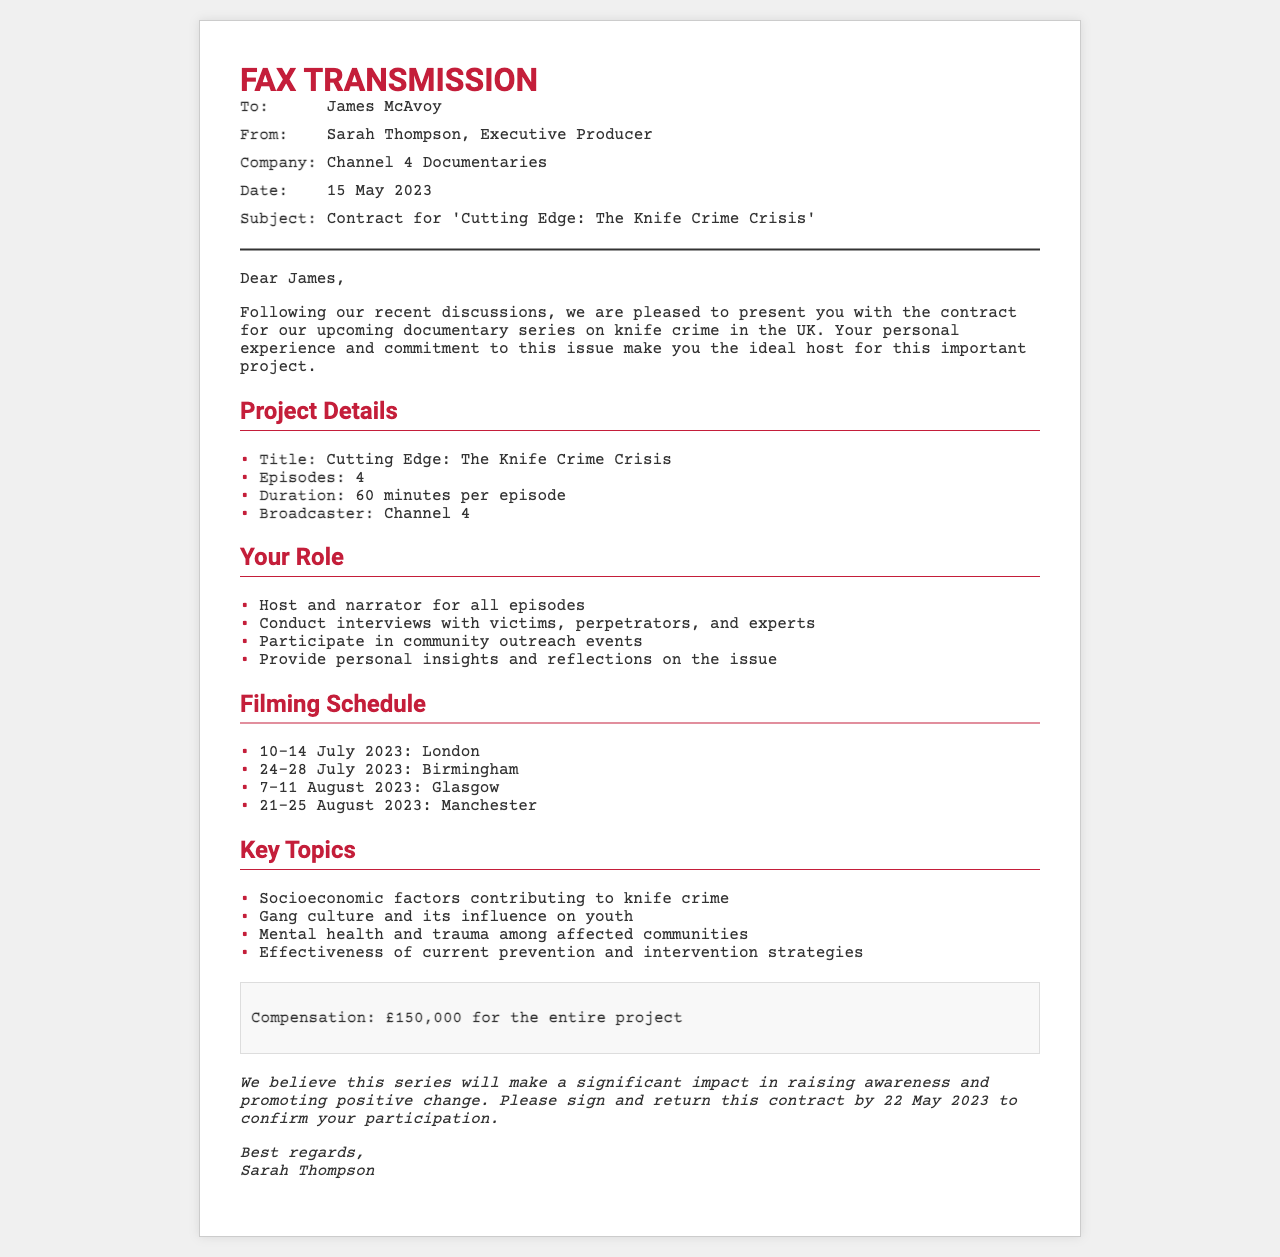what is the title of the documentary series? The title is mentioned in the project details section of the document.
Answer: Cutting Edge: The Knife Crime Crisis who is the sender of the fax? The sender's name is stated in the fax information section.
Answer: Sarah Thompson, Executive Producer how many episodes will the series have? The number of episodes is specified in the project details section.
Answer: 4 when is the filming scheduled in London? The specific dates for filming in London are listed in the filming schedule section.
Answer: 10-14 July 2023 what is the total compensation for the project? The total compensation is provided in the compensation section of the document.
Answer: £150,000 what role will the actor play in the series? The roles for the actor are outlined in the section discussing their role.
Answer: Host and narrator for all episodes which city will filming take place last? The last city mentioned in the filming schedule is specified.
Answer: Manchester what is one of the key topics covered in the documentary? The key topics are listed in the document, highlighting important themes.
Answer: Socioeconomic factors contributing to knife crime 